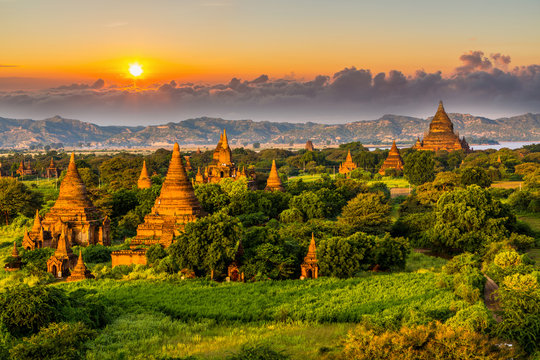How old are these temples? What's their historical significance? The temples in Bagan are centuries old, dating back to the 9th to 13th centuries when the city was the capital of the Pagan Kingdom. This site is significant as it was during this era that Theravada Buddhism first began to flourish in the region, influencing the construction of thousands of temples here as a display of religious devotion and architectural prowess. 